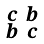<formula> <loc_0><loc_0><loc_500><loc_500>\begin{smallmatrix} c & b \\ b & c \end{smallmatrix}</formula> 